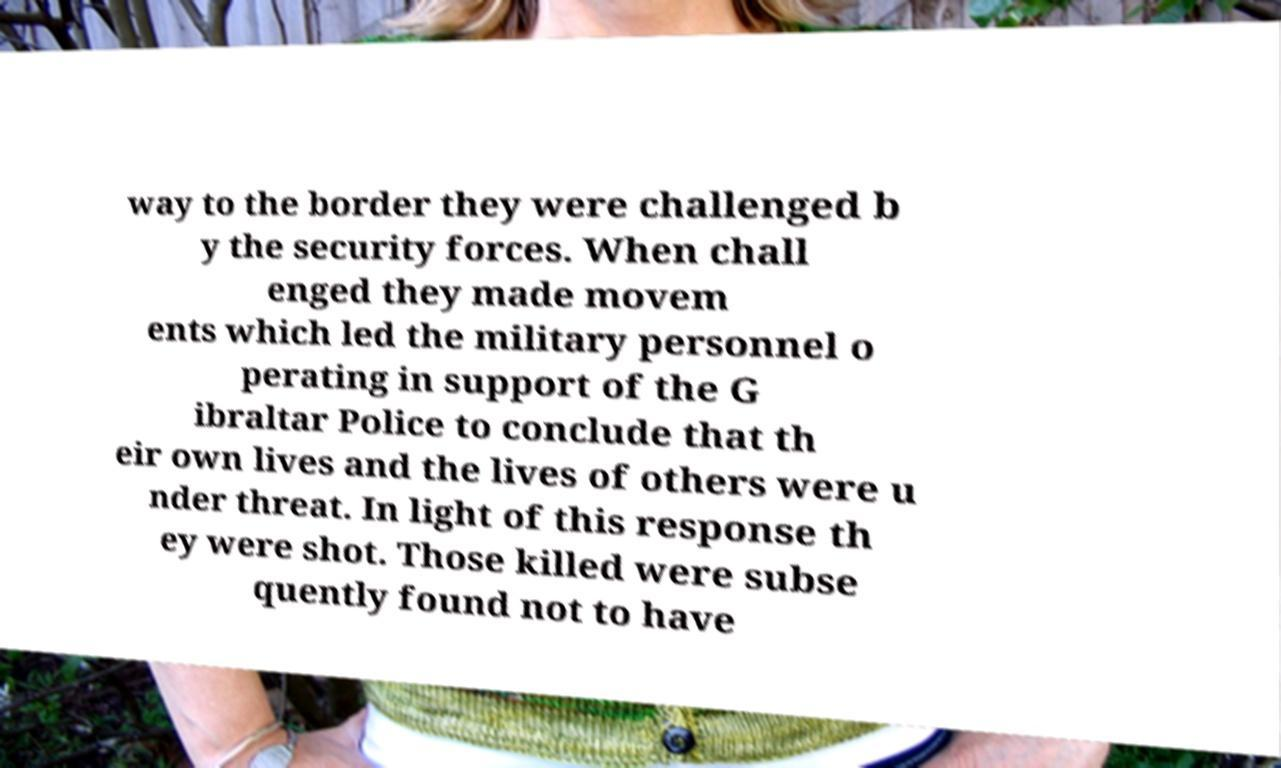Can you accurately transcribe the text from the provided image for me? way to the border they were challenged b y the security forces. When chall enged they made movem ents which led the military personnel o perating in support of the G ibraltar Police to conclude that th eir own lives and the lives of others were u nder threat. In light of this response th ey were shot. Those killed were subse quently found not to have 